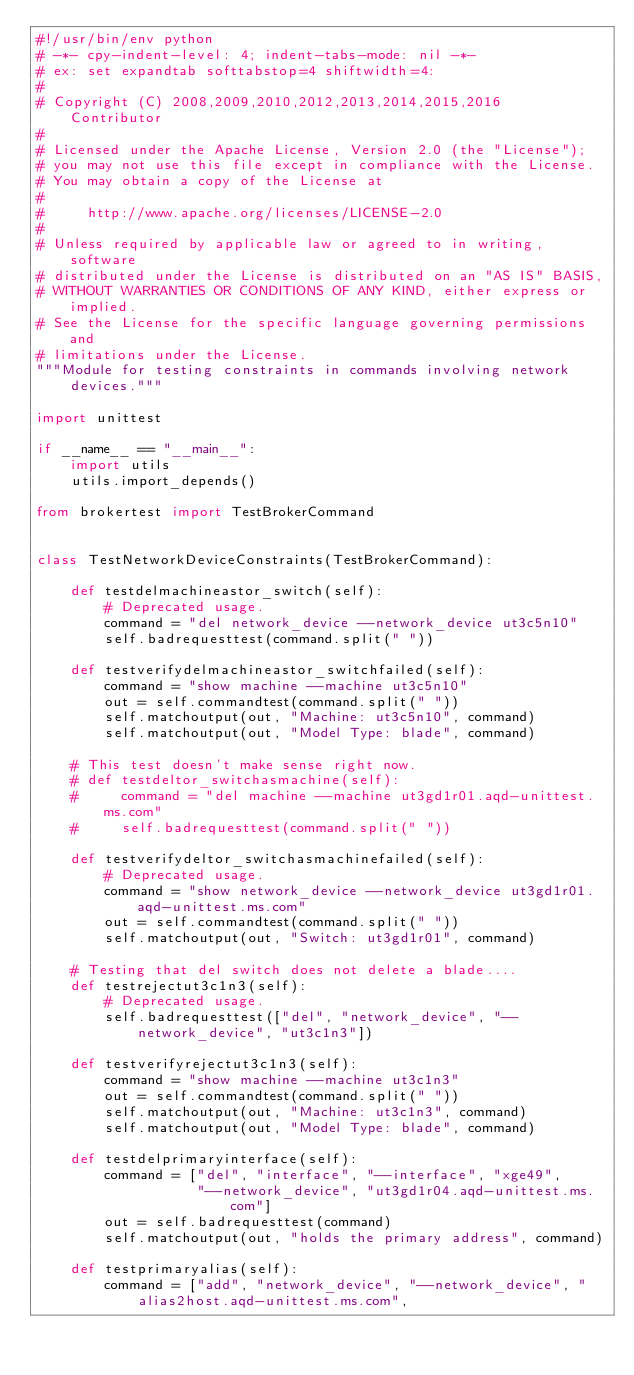<code> <loc_0><loc_0><loc_500><loc_500><_Python_>#!/usr/bin/env python
# -*- cpy-indent-level: 4; indent-tabs-mode: nil -*-
# ex: set expandtab softtabstop=4 shiftwidth=4:
#
# Copyright (C) 2008,2009,2010,2012,2013,2014,2015,2016  Contributor
#
# Licensed under the Apache License, Version 2.0 (the "License");
# you may not use this file except in compliance with the License.
# You may obtain a copy of the License at
#
#     http://www.apache.org/licenses/LICENSE-2.0
#
# Unless required by applicable law or agreed to in writing, software
# distributed under the License is distributed on an "AS IS" BASIS,
# WITHOUT WARRANTIES OR CONDITIONS OF ANY KIND, either express or implied.
# See the License for the specific language governing permissions and
# limitations under the License.
"""Module for testing constraints in commands involving network devices."""

import unittest

if __name__ == "__main__":
    import utils
    utils.import_depends()

from brokertest import TestBrokerCommand


class TestNetworkDeviceConstraints(TestBrokerCommand):

    def testdelmachineastor_switch(self):
        # Deprecated usage.
        command = "del network_device --network_device ut3c5n10"
        self.badrequesttest(command.split(" "))

    def testverifydelmachineastor_switchfailed(self):
        command = "show machine --machine ut3c5n10"
        out = self.commandtest(command.split(" "))
        self.matchoutput(out, "Machine: ut3c5n10", command)
        self.matchoutput(out, "Model Type: blade", command)

    # This test doesn't make sense right now.
    # def testdeltor_switchasmachine(self):
    #     command = "del machine --machine ut3gd1r01.aqd-unittest.ms.com"
    #     self.badrequesttest(command.split(" "))

    def testverifydeltor_switchasmachinefailed(self):
        # Deprecated usage.
        command = "show network_device --network_device ut3gd1r01.aqd-unittest.ms.com"
        out = self.commandtest(command.split(" "))
        self.matchoutput(out, "Switch: ut3gd1r01", command)

    # Testing that del switch does not delete a blade....
    def testrejectut3c1n3(self):
        # Deprecated usage.
        self.badrequesttest(["del", "network_device", "--network_device", "ut3c1n3"])

    def testverifyrejectut3c1n3(self):
        command = "show machine --machine ut3c1n3"
        out = self.commandtest(command.split(" "))
        self.matchoutput(out, "Machine: ut3c1n3", command)
        self.matchoutput(out, "Model Type: blade", command)

    def testdelprimaryinterface(self):
        command = ["del", "interface", "--interface", "xge49",
                   "--network_device", "ut3gd1r04.aqd-unittest.ms.com"]
        out = self.badrequesttest(command)
        self.matchoutput(out, "holds the primary address", command)

    def testprimaryalias(self):
        command = ["add", "network_device", "--network_device", "alias2host.aqd-unittest.ms.com",</code> 